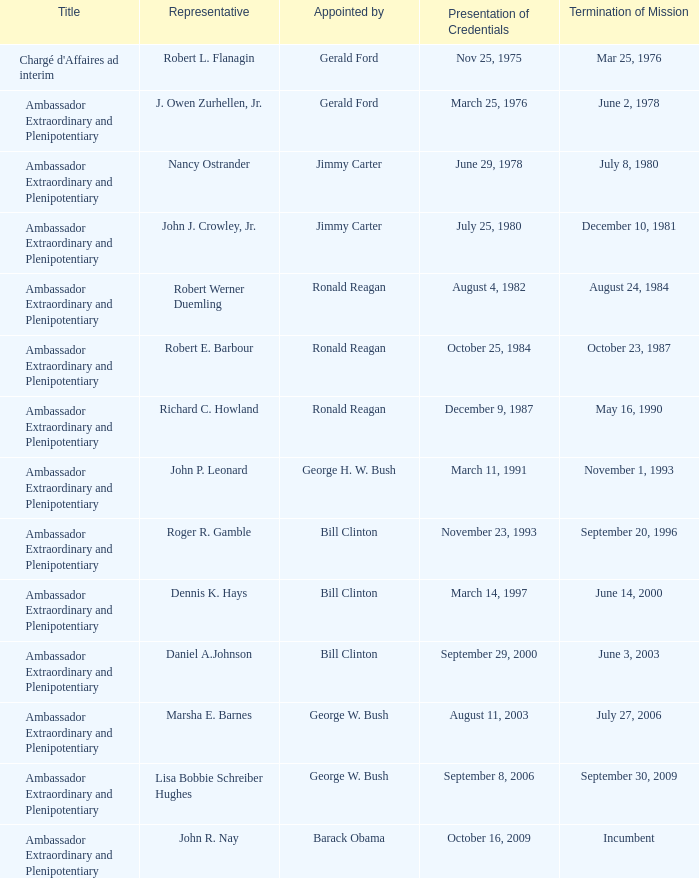What was the Termination of Mission date for the ambassador who was appointed by Barack Obama? Incumbent. 